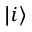Convert formula to latex. <formula><loc_0><loc_0><loc_500><loc_500>| i \rangle</formula> 